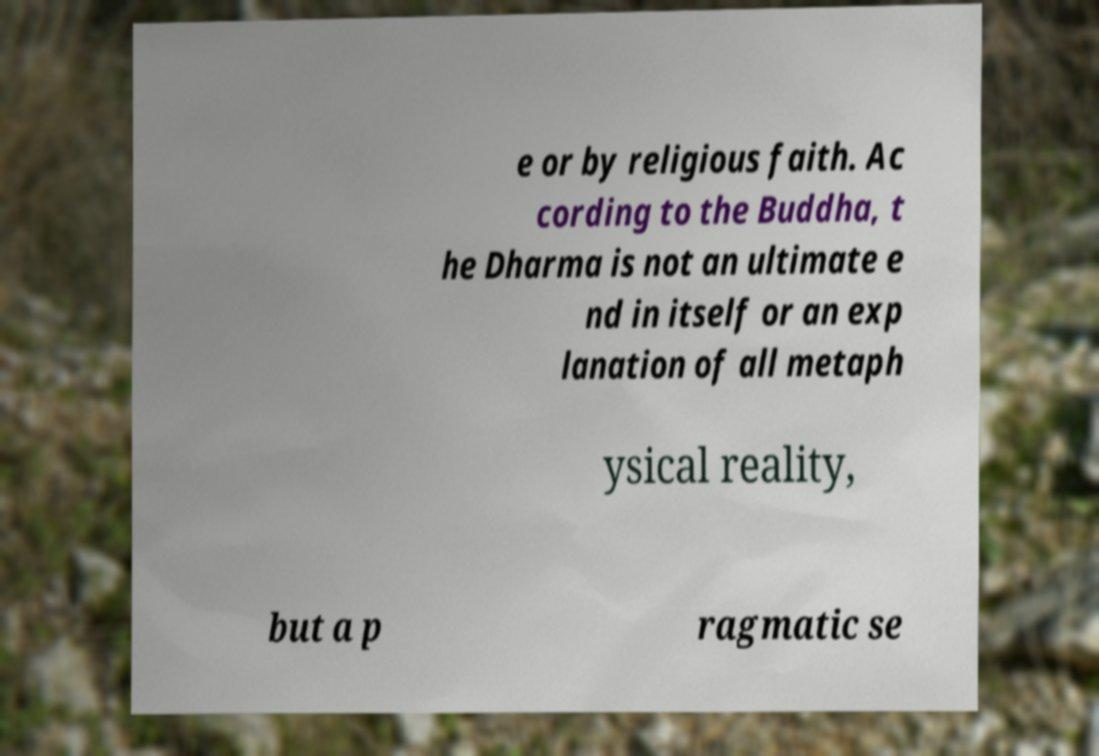Please identify and transcribe the text found in this image. e or by religious faith. Ac cording to the Buddha, t he Dharma is not an ultimate e nd in itself or an exp lanation of all metaph ysical reality, but a p ragmatic se 